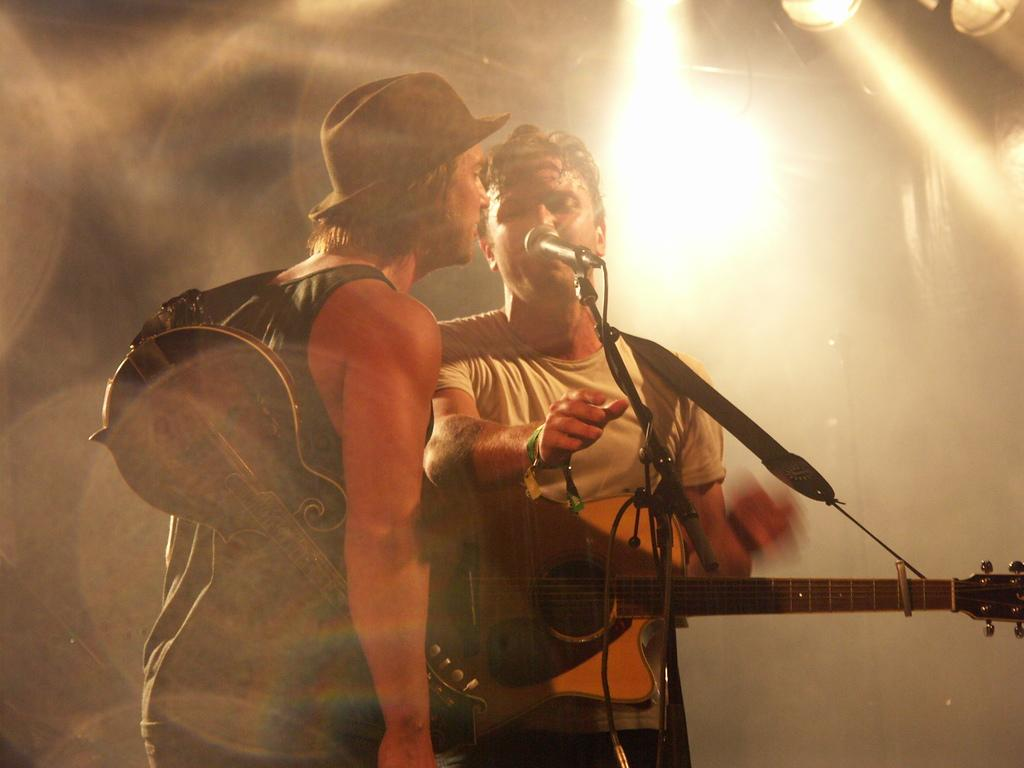How many people are in the image? There are two men in the image. What are the men doing in the image? The men are standing and singing. What objects are the men holding in the image? The men are holding guitars. What is in front of the men? There is a microphone in front of the men. Is there any quicksand visible in the image? No, there is no quicksand present in the image. What type of sign can be seen in the image? There is no sign visible in the image. 